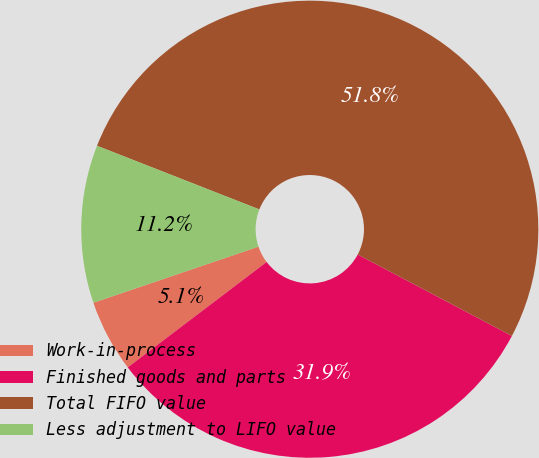Convert chart to OTSL. <chart><loc_0><loc_0><loc_500><loc_500><pie_chart><fcel>Work-in-process<fcel>Finished goods and parts<fcel>Total FIFO value<fcel>Less adjustment to LIFO value<nl><fcel>5.12%<fcel>31.93%<fcel>51.78%<fcel>11.16%<nl></chart> 